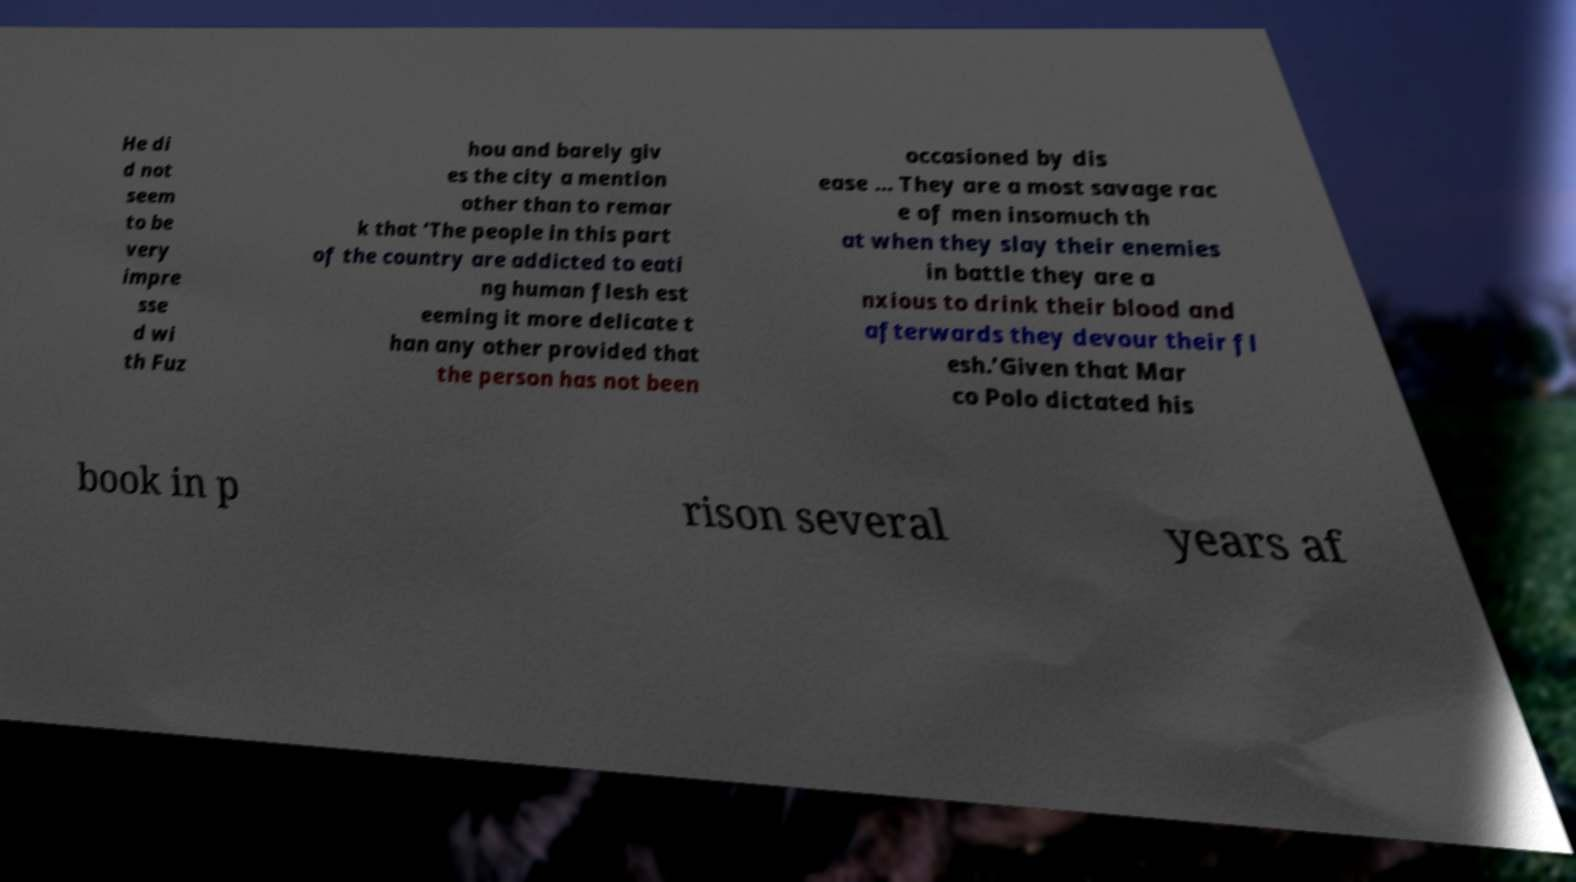What messages or text are displayed in this image? I need them in a readable, typed format. He di d not seem to be very impre sse d wi th Fuz hou and barely giv es the city a mention other than to remar k that ‘The people in this part of the country are addicted to eati ng human flesh est eeming it more delicate t han any other provided that the person has not been occasioned by dis ease … They are a most savage rac e of men insomuch th at when they slay their enemies in battle they are a nxious to drink their blood and afterwards they devour their fl esh.’Given that Mar co Polo dictated his book in p rison several years af 